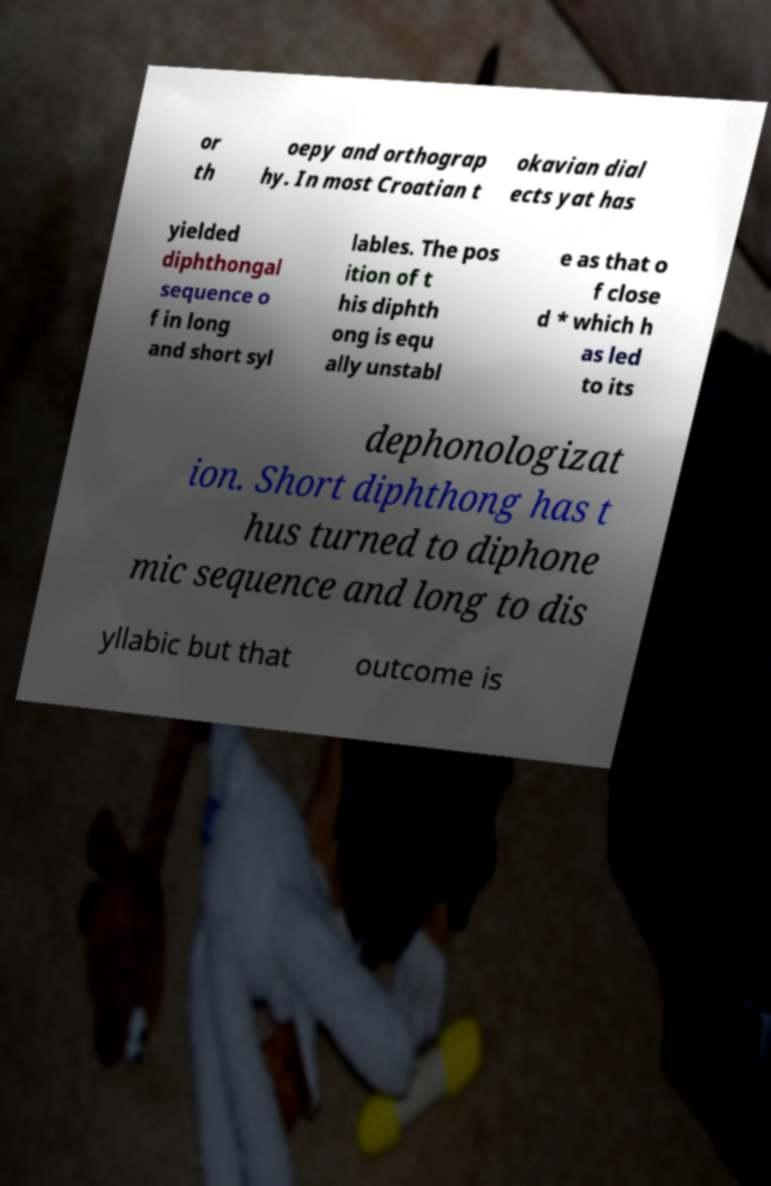Please identify and transcribe the text found in this image. or th oepy and orthograp hy. In most Croatian t okavian dial ects yat has yielded diphthongal sequence o f in long and short syl lables. The pos ition of t his diphth ong is equ ally unstabl e as that o f close d * which h as led to its dephonologizat ion. Short diphthong has t hus turned to diphone mic sequence and long to dis yllabic but that outcome is 